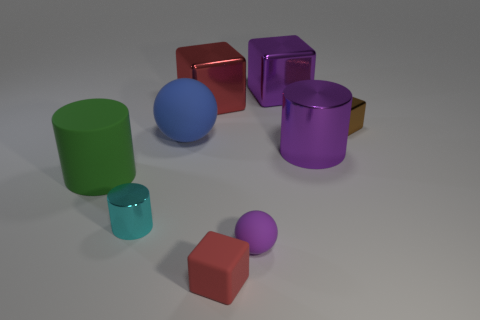There is a object that is the same color as the rubber cube; what shape is it?
Offer a terse response. Cube. Is the number of blue things greater than the number of tiny objects?
Your answer should be compact. No. There is a small shiny object that is to the right of the tiny cylinder; is its color the same as the small matte cube?
Offer a very short reply. No. The rubber cylinder has what color?
Offer a very short reply. Green. There is a purple rubber object left of the small brown metal object; are there any purple balls on the right side of it?
Ensure brevity in your answer.  No. The red object in front of the large blue matte thing that is behind the green rubber cylinder is what shape?
Ensure brevity in your answer.  Cube. Is the number of large rubber things less than the number of large green objects?
Keep it short and to the point. No. Are the small cyan thing and the brown object made of the same material?
Keep it short and to the point. Yes. There is a block that is in front of the red metallic cube and to the left of the tiny brown metal thing; what is its color?
Give a very brief answer. Red. Is there a cyan cube that has the same size as the blue rubber thing?
Offer a terse response. No. 